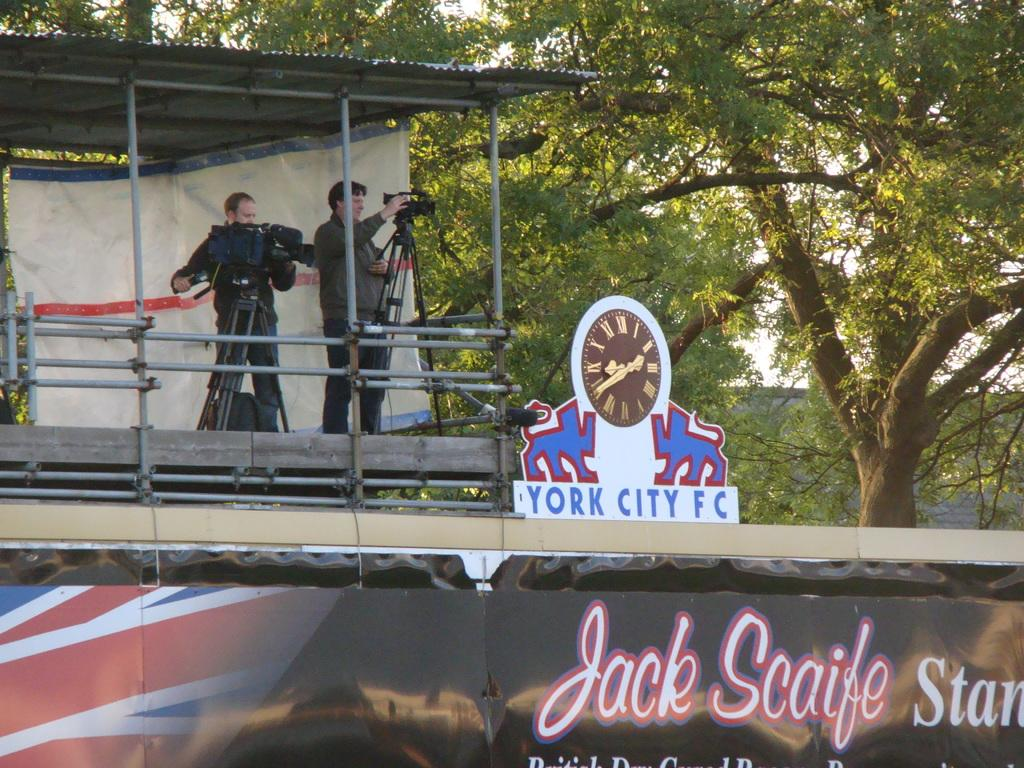Provide a one-sentence caption for the provided image. Two people recording video above a York City FC sign. 